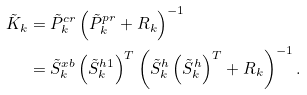Convert formula to latex. <formula><loc_0><loc_0><loc_500><loc_500>\tilde { K } _ { k } & = \tilde { P } ^ { c r } _ { k } \left ( \tilde { P } ^ { p r } _ { k } + R _ { k } \right ) ^ { - 1 } \\ & = \tilde { S } _ { k } ^ { x b } \left ( \tilde { S } _ { k } ^ { h 1 } \right ) ^ { T } \left ( \tilde { S } _ { k } ^ { h } \left ( \tilde { S } _ { k } ^ { h } \right ) ^ { T } + R _ { k } \right ) ^ { - 1 } .</formula> 